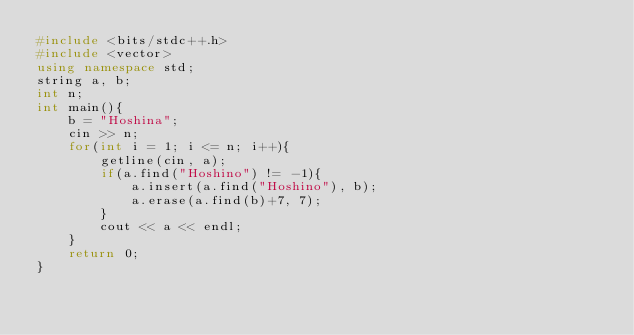Convert code to text. <code><loc_0><loc_0><loc_500><loc_500><_C++_>#include <bits/stdc++.h>
#include <vector>
using namespace std;
string a, b;
int n;
int main(){
	b = "Hoshina";
	cin >> n;
	for(int i = 1; i <= n; i++){
		getline(cin, a);
		if(a.find("Hoshino") != -1){
			a.insert(a.find("Hoshino"), b);
			a.erase(a.find(b)+7, 7);
		}
		cout << a << endl;
	}
	return 0;
}</code> 